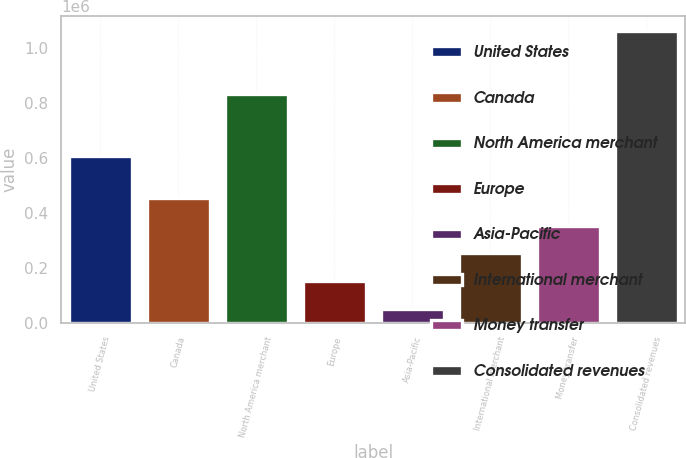Convert chart to OTSL. <chart><loc_0><loc_0><loc_500><loc_500><bar_chart><fcel>United States<fcel>Canada<fcel>North America merchant<fcel>Europe<fcel>Asia-Pacific<fcel>International merchant<fcel>Money transfer<fcel>Consolidated revenues<nl><fcel>604899<fcel>453679<fcel>829469<fcel>149756<fcel>48449<fcel>251064<fcel>352371<fcel>1.06152e+06<nl></chart> 